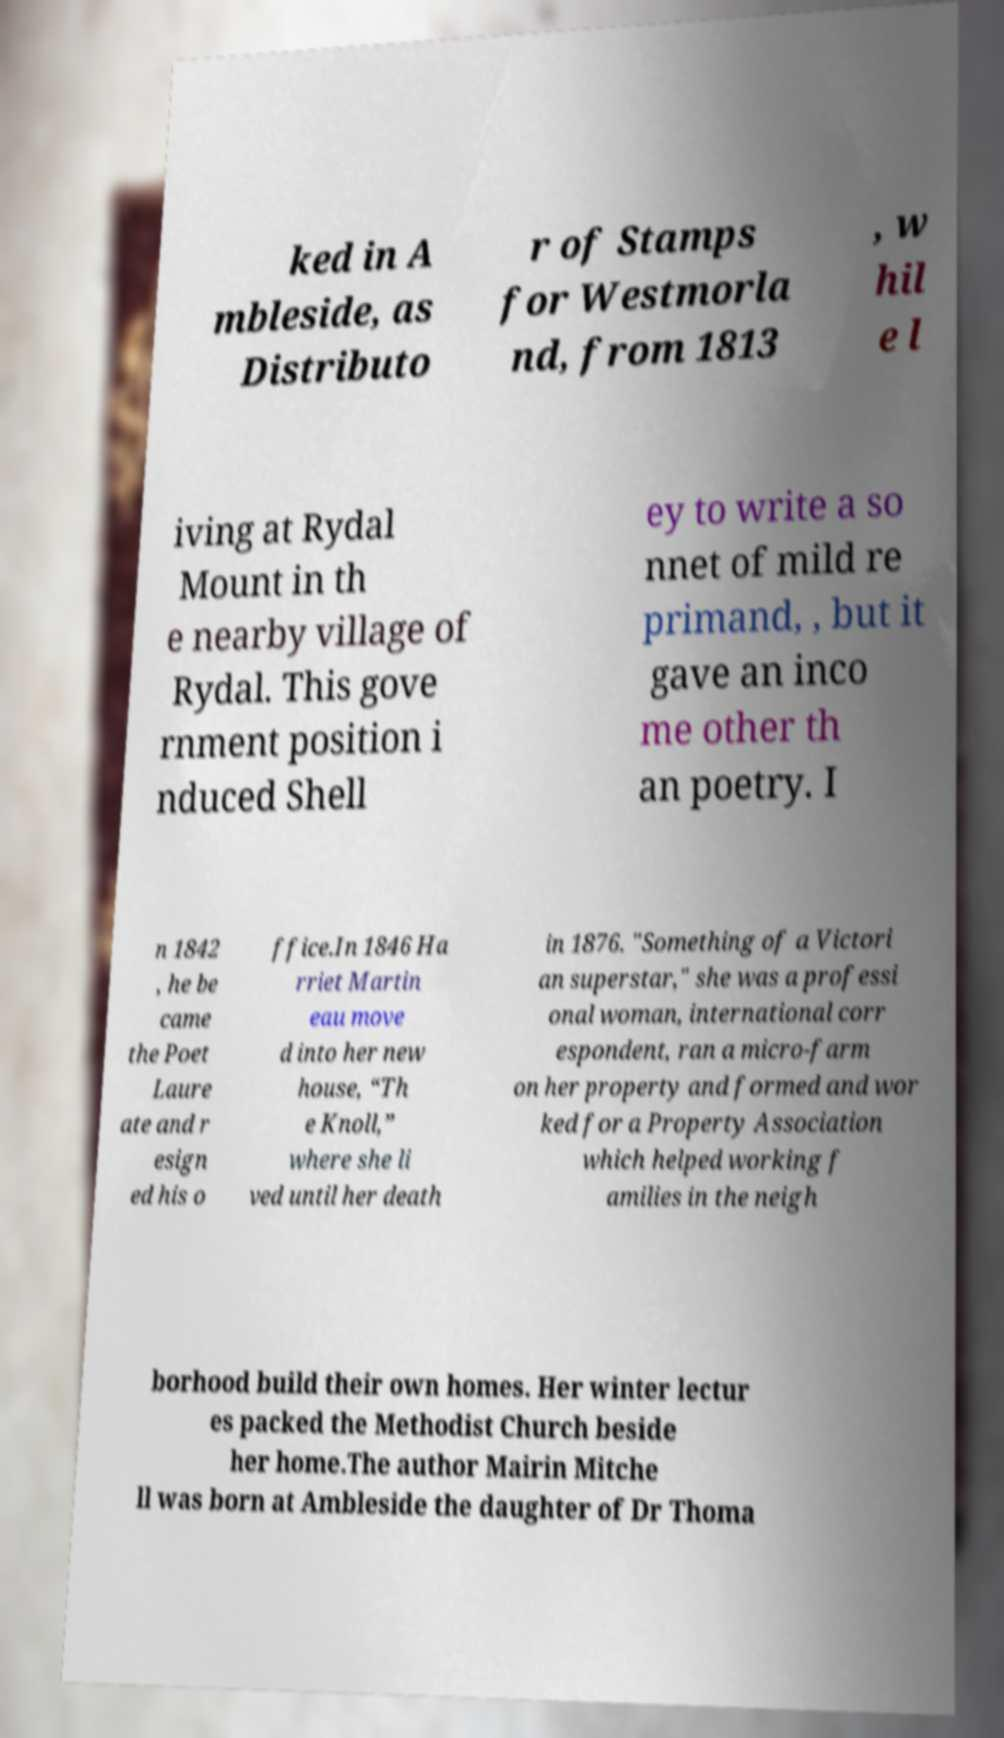Can you accurately transcribe the text from the provided image for me? ked in A mbleside, as Distributo r of Stamps for Westmorla nd, from 1813 , w hil e l iving at Rydal Mount in th e nearby village of Rydal. This gove rnment position i nduced Shell ey to write a so nnet of mild re primand, , but it gave an inco me other th an poetry. I n 1842 , he be came the Poet Laure ate and r esign ed his o ffice.In 1846 Ha rriet Martin eau move d into her new house, “Th e Knoll,” where she li ved until her death in 1876. "Something of a Victori an superstar," she was a professi onal woman, international corr espondent, ran a micro-farm on her property and formed and wor ked for a Property Association which helped working f amilies in the neigh borhood build their own homes. Her winter lectur es packed the Methodist Church beside her home.The author Mairin Mitche ll was born at Ambleside the daughter of Dr Thoma 